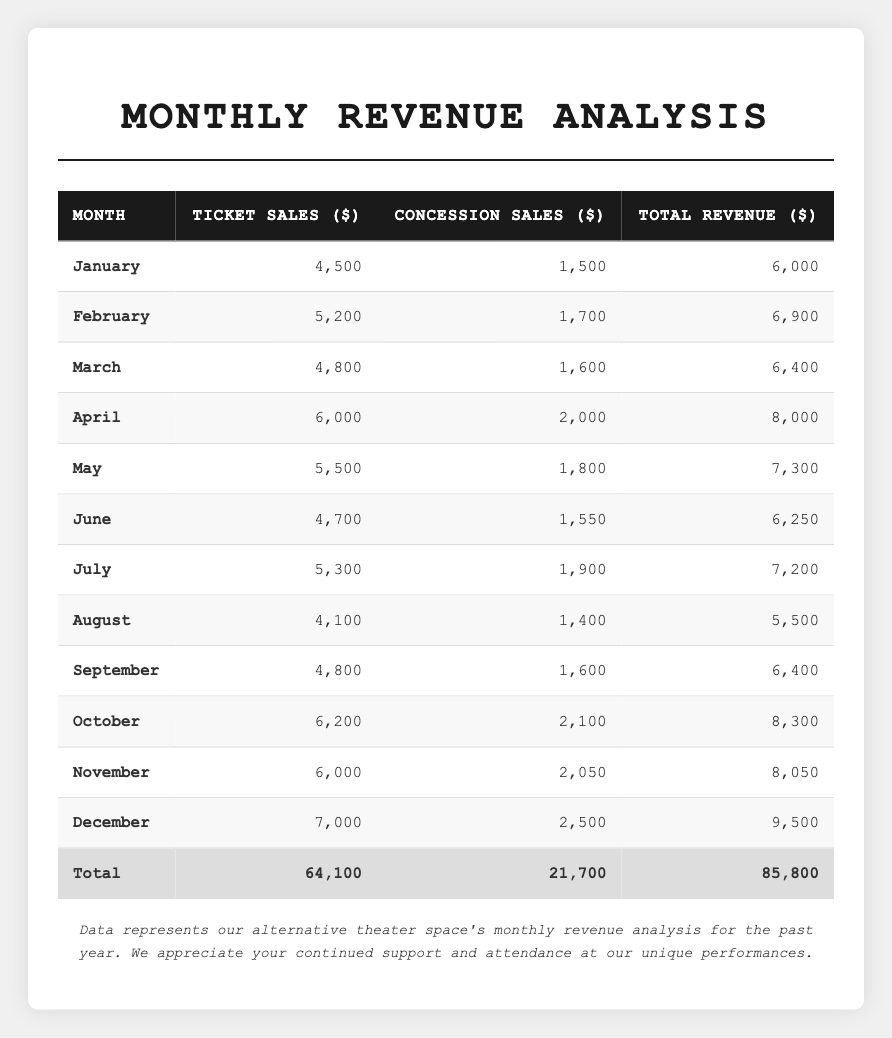What was the total revenue for December? The table lists December's total revenue under the "Total Revenue" column, which is 9,500 dollars.
Answer: 9,500 Which month had the highest ticket sales? In the "Ticket Sales" column, December shows the highest value at 7,000 dollars.
Answer: December What is the total revenue from January to June? To find the total from January to June, sum the total revenues for each month: 6,000 + 6,900 + 6,400 + 8,000 + 7,300 + 6,250 = 40,850 dollars.
Answer: 40,850 Did concession sales increase every month? Analyzing the "Concession Sales" column, the values do not consistently increase; for example, from May to June, concession sales decreased from 1,800 to 1,550 dollars.
Answer: No What is the difference between total revenue in October and August? The total revenue for October is 8,300 dollars, and for August, it's 5,500 dollars. The difference is 8,300 - 5,500 = 2,800 dollars.
Answer: 2,800 What is the average monthly ticket sales over the year? The total ticket sales are 64,100 dollars, and there are 12 months. The average is 64,100 / 12 = 5,342 dollars, rounded to the nearest dollar.
Answer: 5,342 Which month saw a decrease in ticket sales compared to the previous month? Looking at the "Ticket Sales" column month by month, August has lower ticket sales (4,100 dollars) compared to July (5,300 dollars), indicating a decrease.
Answer: August What was the total revenue for the second half of the year (July to December)? The total revenues for July to December are: 7,200 + 5,500 + 6,400 + 8,300 + 8,050 + 9,500 = 44,950 dollars.
Answer: 44,950 Which month had the smallest total revenue? By examining the "Total Revenue" column, August shows the smallest total revenue at 5,500 dollars.
Answer: August What is the percentage increase in total revenue from January (6,000) to April (8,000)? The increase from January to April is 8,000 - 6,000 = 2,000 dollars. The percentage increase is (2,000 / 6,000) * 100% ≈ 33.33%.
Answer: Approximately 33.33% 